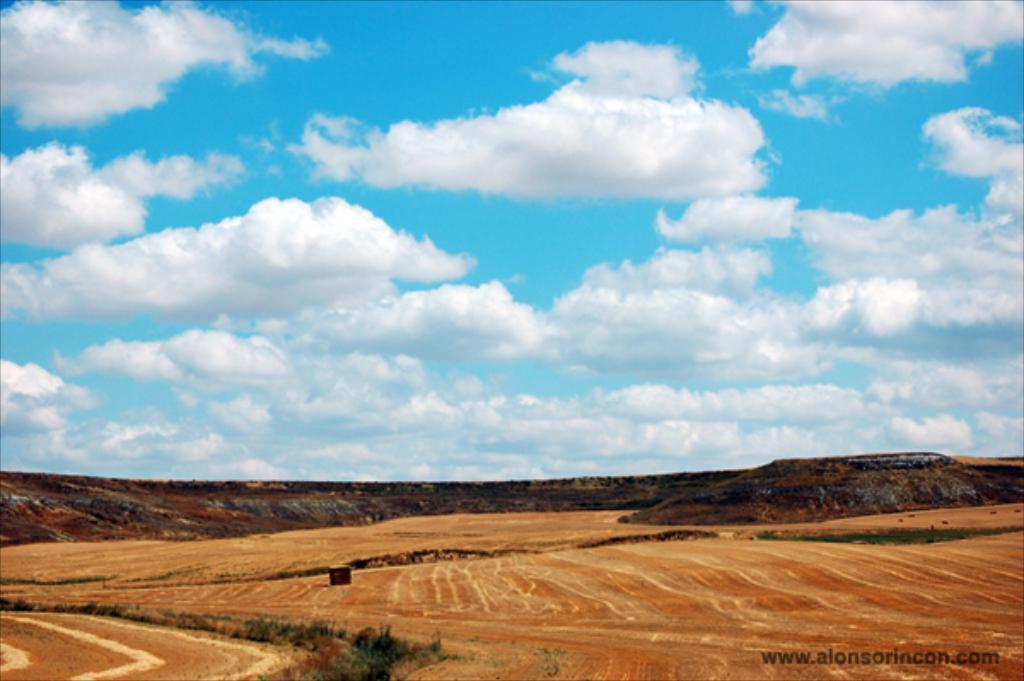Describe this image in one or two sentences. At the bottom of the picture there are fields, trees and hills. Sky is sunny. 